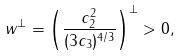Convert formula to latex. <formula><loc_0><loc_0><loc_500><loc_500>w ^ { \perp } = \left ( \frac { c _ { 2 } ^ { 2 } } { ( 3 c _ { 3 } ) ^ { 4 / 3 } } \right ) ^ { \perp } > 0 ,</formula> 